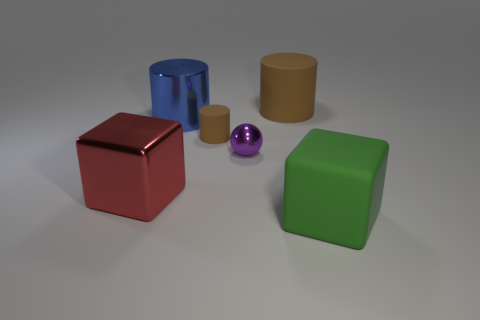Subtract all big matte cylinders. How many cylinders are left? 2 Subtract 2 cylinders. How many cylinders are left? 1 Subtract all green cubes. How many cubes are left? 1 Subtract all blocks. How many objects are left? 4 Subtract all blue cubes. Subtract all gray balls. How many cubes are left? 2 Subtract all red balls. How many green cubes are left? 1 Subtract all tiny cyan metallic balls. Subtract all large brown matte cylinders. How many objects are left? 5 Add 4 large red metal objects. How many large red metal objects are left? 5 Add 2 gray rubber things. How many gray rubber things exist? 2 Add 1 blue things. How many objects exist? 7 